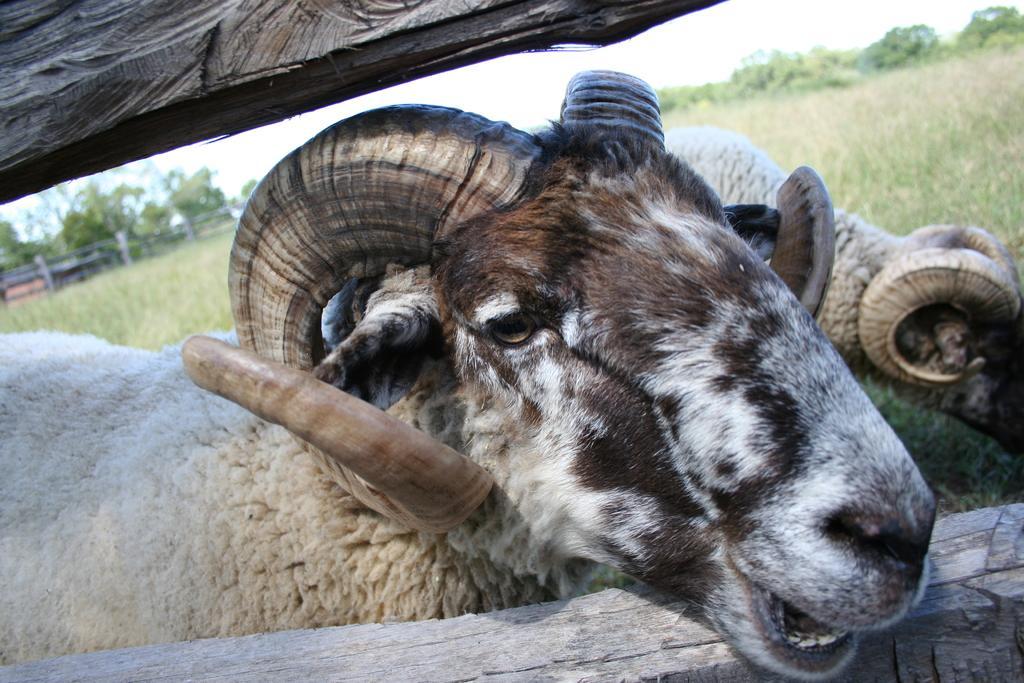In one or two sentences, can you explain what this image depicts? In this image we can see bighorn sheep. In the background there are grass, trees, sky and wooden fence. 